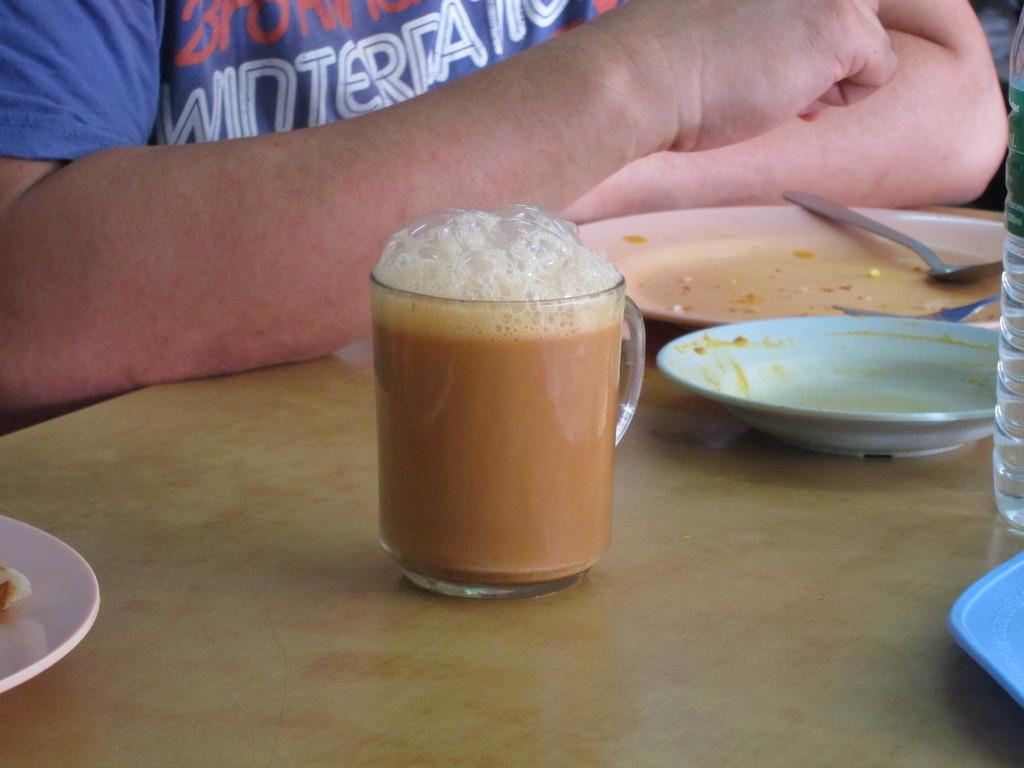What is in the cup that is visible in the image? There is tea in a cup in the image. What other items can be seen on the table in the image? There are plates and spoons visible in the image. What is the color of the table in the image? The table is brown in color. What else is present on the table in the image? There is a bottle on the table. Can you describe the person visible in the background of the image? Unfortunately, the facts provided do not give enough information to describe the person in the background. What type of produce is being harvested by the airplane in the image? There is no airplane or produce present in the image. 